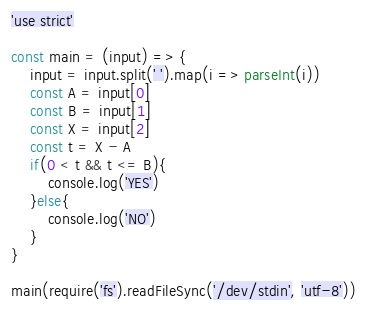<code> <loc_0><loc_0><loc_500><loc_500><_JavaScript_>'use strict'

const main = (input) => {
    input = input.split(' ').map(i => parseInt(i))
    const A = input[0]
    const B = input[1]
    const X = input[2]
    const t = X - A
    if(0 < t && t <= B){
        console.log('YES')
    }else{
        console.log('NO')
    }
}

main(require('fs').readFileSync('/dev/stdin', 'utf-8'))</code> 